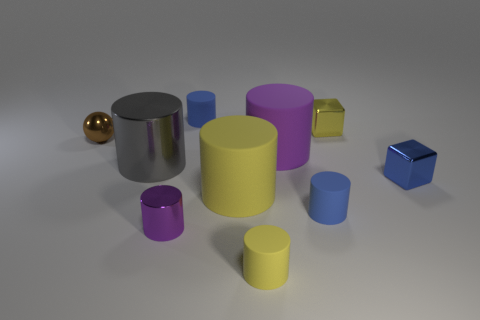Subtract all tiny purple shiny cylinders. How many cylinders are left? 6 Subtract all blue cylinders. How many cylinders are left? 5 Subtract 2 blocks. How many blocks are left? 0 Subtract all small blue cubes. Subtract all purple metallic objects. How many objects are left? 8 Add 4 large objects. How many large objects are left? 7 Add 9 tiny cyan rubber spheres. How many tiny cyan rubber spheres exist? 9 Subtract 0 cyan cylinders. How many objects are left? 10 Subtract all cylinders. How many objects are left? 3 Subtract all green cylinders. Subtract all cyan blocks. How many cylinders are left? 7 Subtract all blue spheres. How many yellow blocks are left? 1 